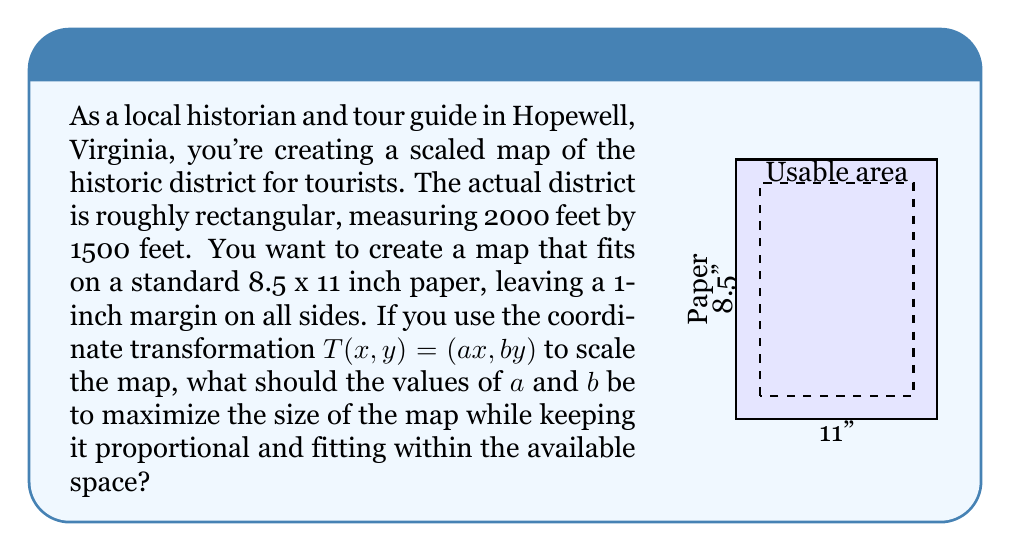Could you help me with this problem? Let's approach this step-by-step:

1) First, we need to determine the usable area on the paper:
   Width: 8.5 - 2 = 6.5 inches
   Height: 11 - 2 = 9 inches

2) The ratio of the actual district is:
   $$\frac{2000}{1500} = \frac{4}{3}$$

3) To maintain this ratio, our scaled map must also have a 4:3 ratio. Let's call the scaled width $w$ and height $h$:
   $$\frac{w}{h} = \frac{4}{3}$$

4) We have two constraints:
   $w \leq 6.5$ and $h \leq 9$

5) To maximize the size, one of these constraints must be met exactly. Let's try width:
   If $w = 6.5$, then $h = 6.5 * (3/4) = 4.875$
   This fits within our height constraint, so we'll use these values.

6) Now, we can calculate $a$ and $b$:
   $$a = \frac{6.5}{2000} = 0.00325$$
   $$b = \frac{4.875}{1500} = 0.00325$$

7) We can verify that $a = b$, which ensures the scaling is uniform and proportional.
Answer: $a = b = 0.00325$ 